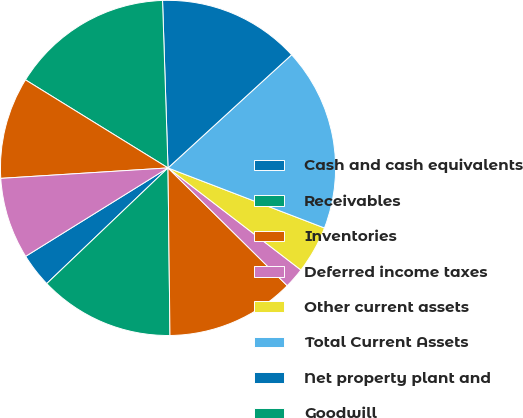<chart> <loc_0><loc_0><loc_500><loc_500><pie_chart><fcel>Cash and cash equivalents<fcel>Receivables<fcel>Inventories<fcel>Deferred income taxes<fcel>Other current assets<fcel>Total Current Assets<fcel>Net property plant and<fcel>Goodwill<fcel>Other intangibles<fcel>Other assets<nl><fcel>3.28%<fcel>13.06%<fcel>12.41%<fcel>1.98%<fcel>4.59%<fcel>17.63%<fcel>13.72%<fcel>15.67%<fcel>9.8%<fcel>7.85%<nl></chart> 